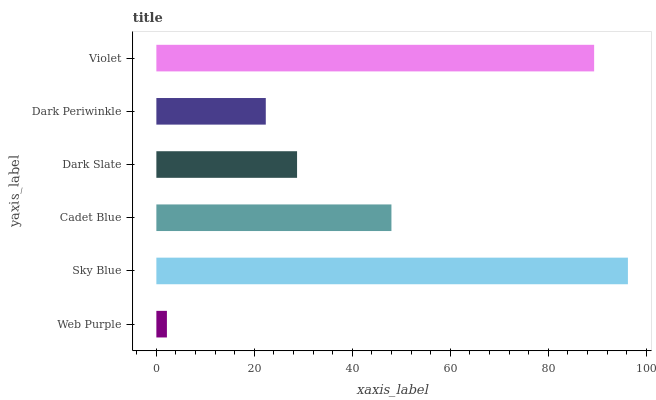Is Web Purple the minimum?
Answer yes or no. Yes. Is Sky Blue the maximum?
Answer yes or no. Yes. Is Cadet Blue the minimum?
Answer yes or no. No. Is Cadet Blue the maximum?
Answer yes or no. No. Is Sky Blue greater than Cadet Blue?
Answer yes or no. Yes. Is Cadet Blue less than Sky Blue?
Answer yes or no. Yes. Is Cadet Blue greater than Sky Blue?
Answer yes or no. No. Is Sky Blue less than Cadet Blue?
Answer yes or no. No. Is Cadet Blue the high median?
Answer yes or no. Yes. Is Dark Slate the low median?
Answer yes or no. Yes. Is Sky Blue the high median?
Answer yes or no. No. Is Sky Blue the low median?
Answer yes or no. No. 